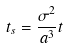<formula> <loc_0><loc_0><loc_500><loc_500>t _ { s } = \frac { \sigma ^ { 2 } } { a ^ { 3 } } t</formula> 